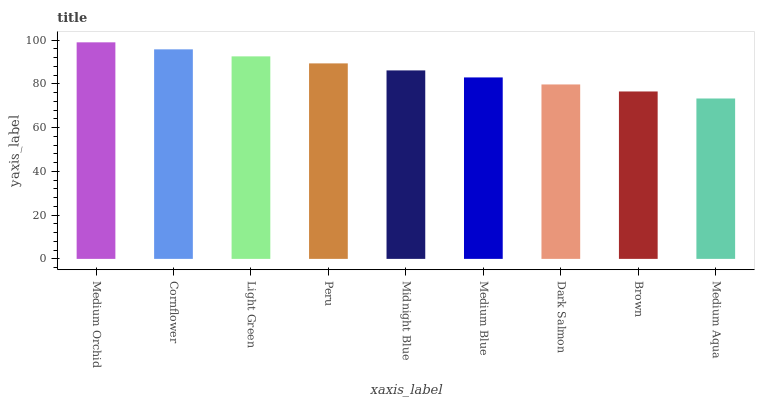Is Medium Aqua the minimum?
Answer yes or no. Yes. Is Medium Orchid the maximum?
Answer yes or no. Yes. Is Cornflower the minimum?
Answer yes or no. No. Is Cornflower the maximum?
Answer yes or no. No. Is Medium Orchid greater than Cornflower?
Answer yes or no. Yes. Is Cornflower less than Medium Orchid?
Answer yes or no. Yes. Is Cornflower greater than Medium Orchid?
Answer yes or no. No. Is Medium Orchid less than Cornflower?
Answer yes or no. No. Is Midnight Blue the high median?
Answer yes or no. Yes. Is Midnight Blue the low median?
Answer yes or no. Yes. Is Medium Blue the high median?
Answer yes or no. No. Is Medium Blue the low median?
Answer yes or no. No. 